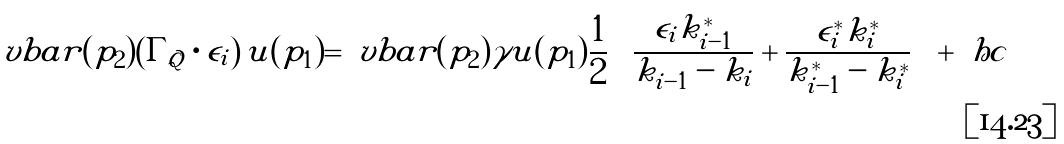Convert formula to latex. <formula><loc_0><loc_0><loc_500><loc_500>\ v b a r ( p _ { 2 } ) \left ( \Gamma _ { \mathcal { Q } } \cdot \epsilon _ { i } \right ) u ( p _ { 1 } ) = \ v b a r ( p _ { 2 } ) \gamma u ( p _ { 1 } ) \frac { 1 } { 2 } \left ( \frac { \epsilon _ { i } k _ { i - 1 } ^ { * } } { k _ { i - 1 } - k _ { i } } + \frac { \epsilon _ { i } ^ { * } k _ { i } ^ { * } } { k _ { i - 1 } ^ { * } - k _ { i } ^ { * } } \right ) + \ h c</formula> 